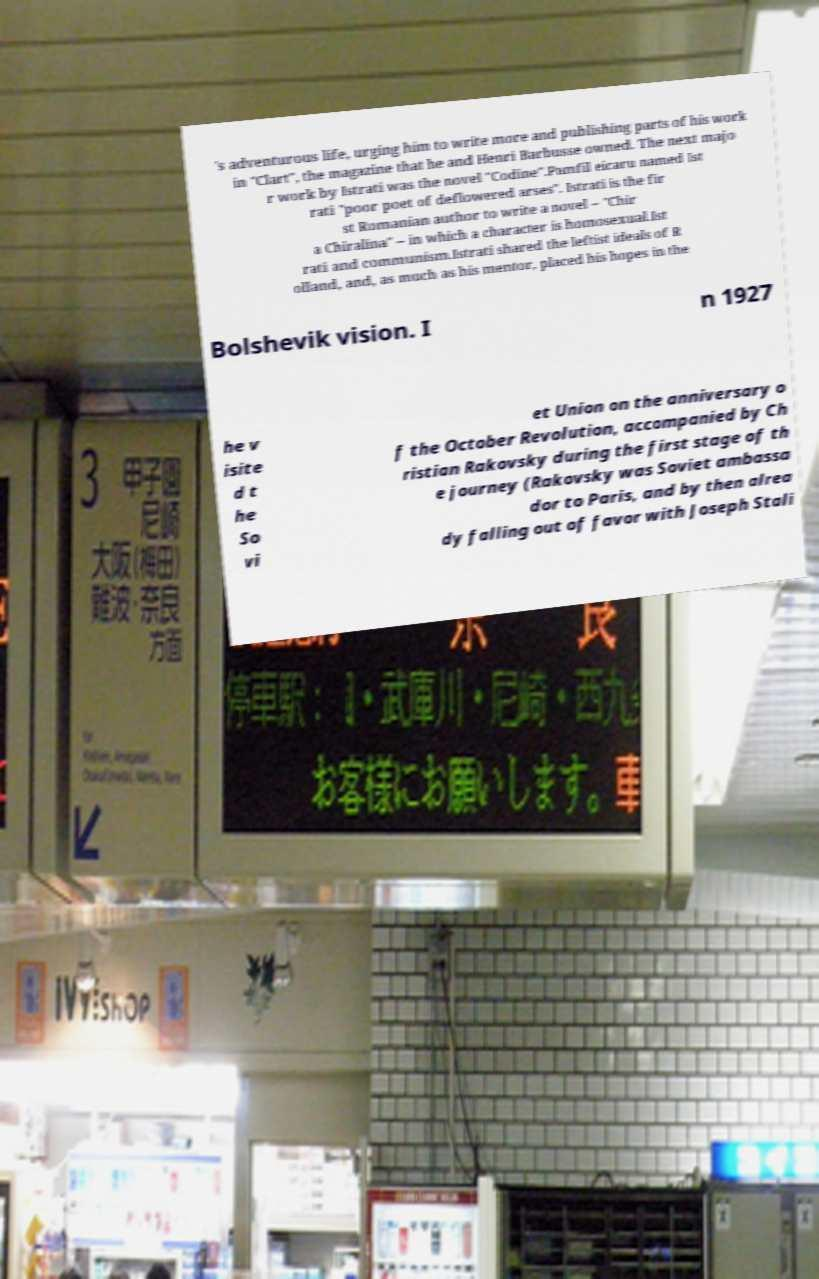Could you extract and type out the text from this image? 's adventurous life, urging him to write more and publishing parts of his work in "Clart", the magazine that he and Henri Barbusse owned. The next majo r work by Istrati was the novel "Codine".Pamfil eicaru named Ist rati "poor poet of deflowered arses". Istrati is the fir st Romanian author to write a novel – "Chir a Chiralina" – in which a character is homosexual.Ist rati and communism.Istrati shared the leftist ideals of R olland, and, as much as his mentor, placed his hopes in the Bolshevik vision. I n 1927 he v isite d t he So vi et Union on the anniversary o f the October Revolution, accompanied by Ch ristian Rakovsky during the first stage of th e journey (Rakovsky was Soviet ambassa dor to Paris, and by then alrea dy falling out of favor with Joseph Stali 